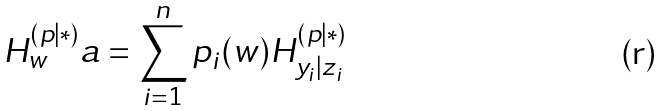<formula> <loc_0><loc_0><loc_500><loc_500>H ^ { ( p | \ast ) } _ { w } a = \sum _ { i = 1 } ^ { n } p _ { i } ( w ) H ^ { ( p | \ast ) } _ { y _ { i } | z _ { i } }</formula> 